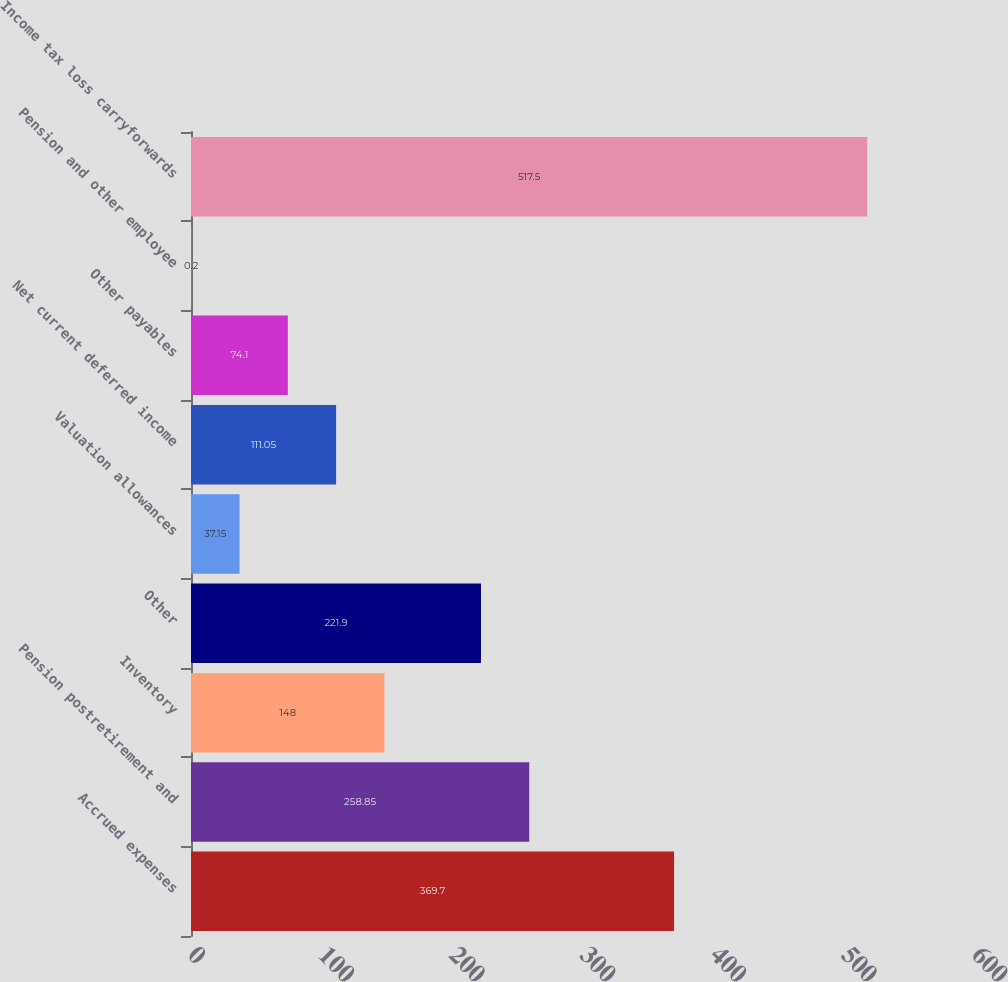Convert chart. <chart><loc_0><loc_0><loc_500><loc_500><bar_chart><fcel>Accrued expenses<fcel>Pension postretirement and<fcel>Inventory<fcel>Other<fcel>Valuation allowances<fcel>Net current deferred income<fcel>Other payables<fcel>Pension and other employee<fcel>Income tax loss carryforwards<nl><fcel>369.7<fcel>258.85<fcel>148<fcel>221.9<fcel>37.15<fcel>111.05<fcel>74.1<fcel>0.2<fcel>517.5<nl></chart> 